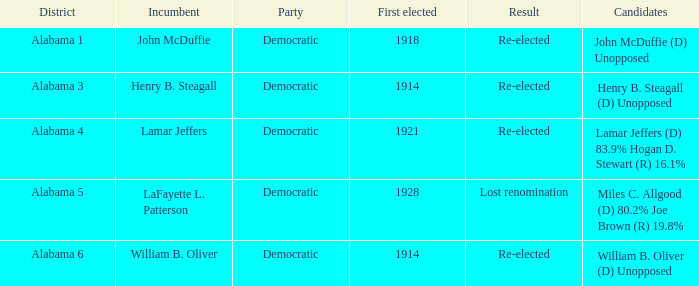What kind of party is the district in Alabama 1? Democratic. 